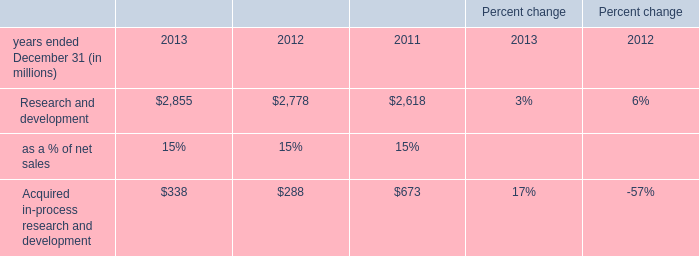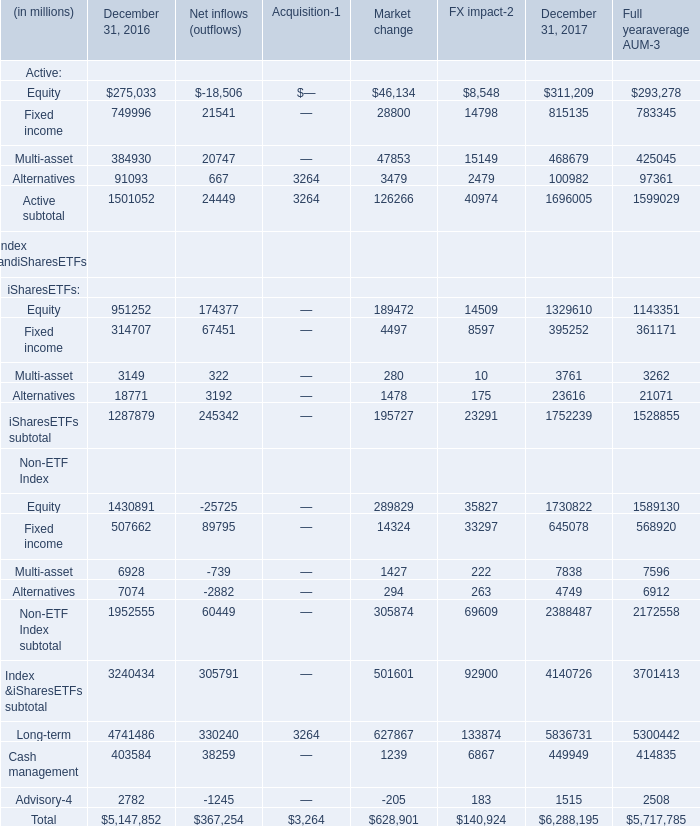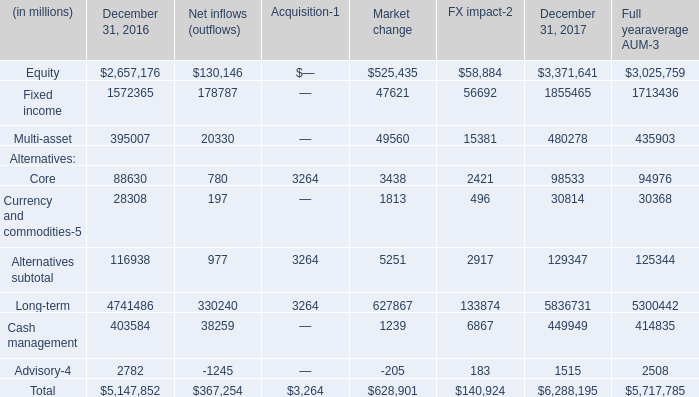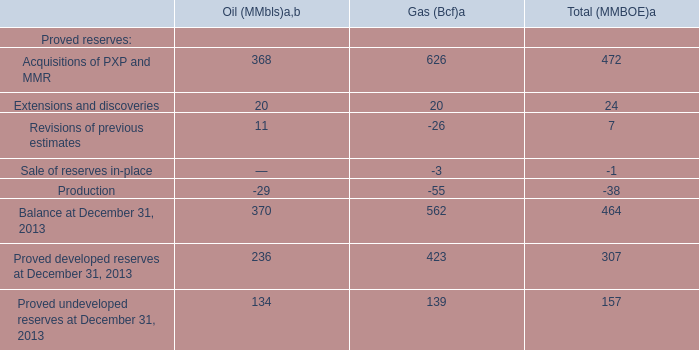In the year with largest amount of Equity in table 2, what's the increasing rate of Multi-asset in table 2? 
Computations: ((480278 - 395007) / 395007)
Answer: 0.21587. 